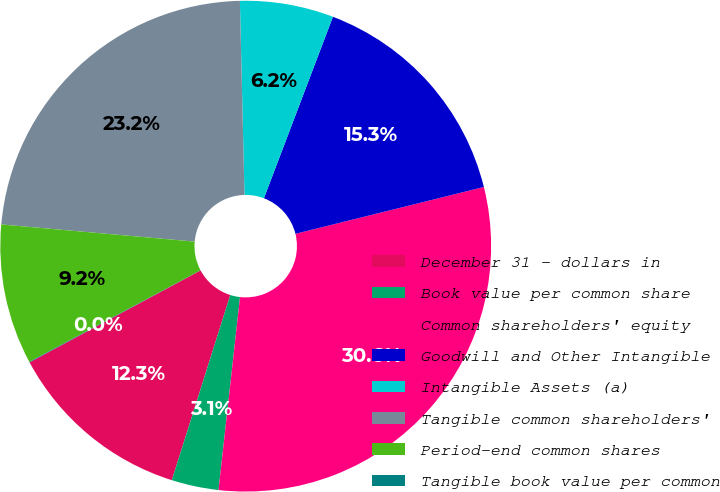<chart> <loc_0><loc_0><loc_500><loc_500><pie_chart><fcel>December 31 - dollars in<fcel>Book value per common share<fcel>Common shareholders' equity<fcel>Goodwill and Other Intangible<fcel>Intangible Assets (a)<fcel>Tangible common shareholders'<fcel>Period-end common shares<fcel>Tangible book value per common<nl><fcel>12.28%<fcel>3.1%<fcel>30.64%<fcel>15.34%<fcel>6.16%<fcel>23.21%<fcel>9.22%<fcel>0.04%<nl></chart> 